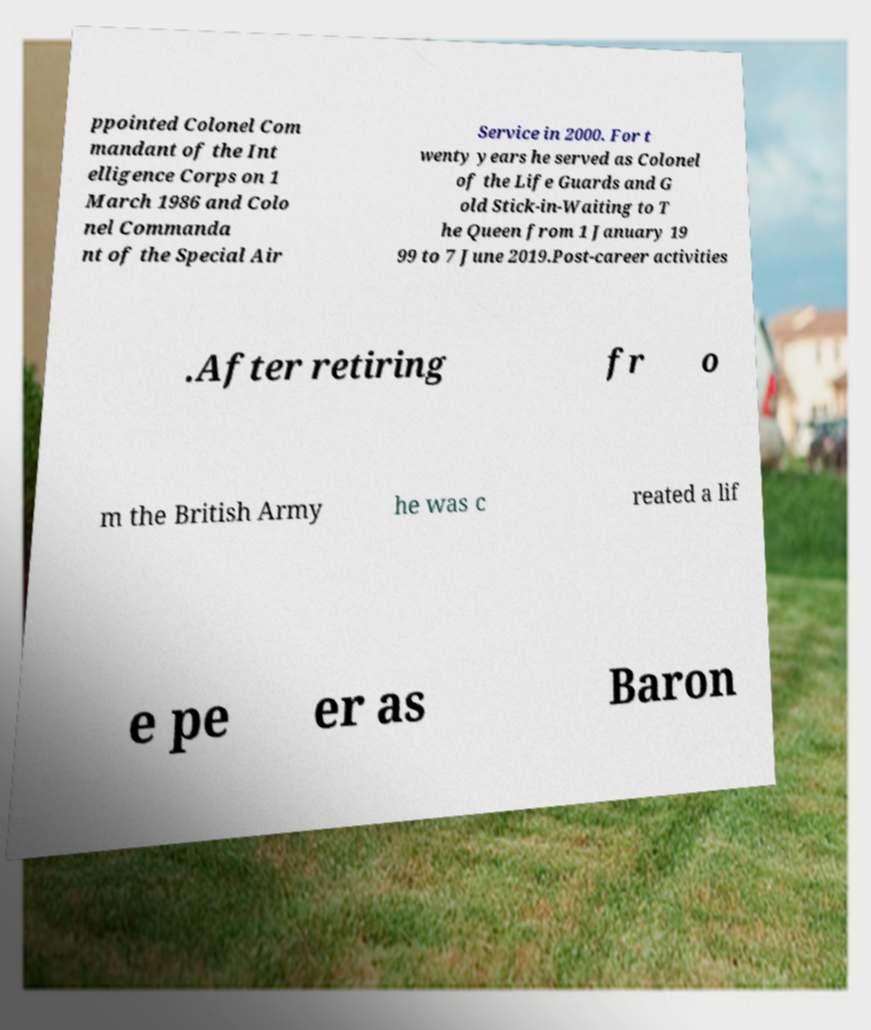There's text embedded in this image that I need extracted. Can you transcribe it verbatim? ppointed Colonel Com mandant of the Int elligence Corps on 1 March 1986 and Colo nel Commanda nt of the Special Air Service in 2000. For t wenty years he served as Colonel of the Life Guards and G old Stick-in-Waiting to T he Queen from 1 January 19 99 to 7 June 2019.Post-career activities .After retiring fr o m the British Army he was c reated a lif e pe er as Baron 